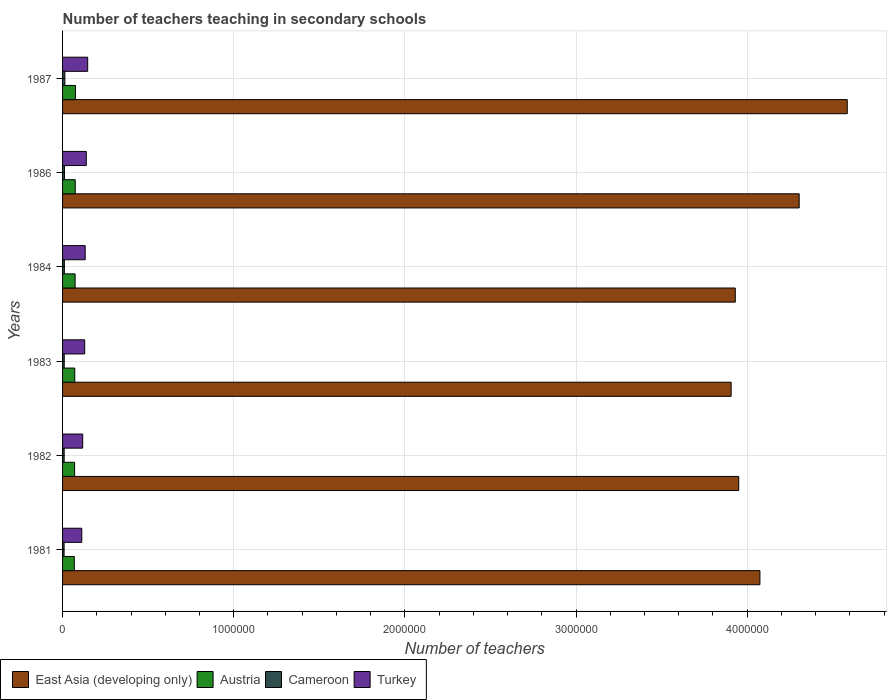How many groups of bars are there?
Your response must be concise. 6. How many bars are there on the 2nd tick from the bottom?
Keep it short and to the point. 4. What is the label of the 2nd group of bars from the top?
Your answer should be compact. 1986. In how many cases, is the number of bars for a given year not equal to the number of legend labels?
Your answer should be very brief. 0. What is the number of teachers teaching in secondary schools in Turkey in 1987?
Offer a terse response. 1.47e+05. Across all years, what is the maximum number of teachers teaching in secondary schools in Austria?
Provide a succinct answer. 7.53e+04. Across all years, what is the minimum number of teachers teaching in secondary schools in Austria?
Your response must be concise. 6.85e+04. In which year was the number of teachers teaching in secondary schools in Turkey maximum?
Offer a very short reply. 1987. What is the total number of teachers teaching in secondary schools in Turkey in the graph?
Your response must be concise. 7.77e+05. What is the difference between the number of teachers teaching in secondary schools in East Asia (developing only) in 1982 and that in 1986?
Ensure brevity in your answer.  -3.53e+05. What is the difference between the number of teachers teaching in secondary schools in Cameroon in 1987 and the number of teachers teaching in secondary schools in Turkey in 1983?
Your answer should be compact. -1.16e+05. What is the average number of teachers teaching in secondary schools in East Asia (developing only) per year?
Your answer should be very brief. 4.13e+06. In the year 1986, what is the difference between the number of teachers teaching in secondary schools in Austria and number of teachers teaching in secondary schools in Cameroon?
Your answer should be very brief. 6.29e+04. In how many years, is the number of teachers teaching in secondary schools in Turkey greater than 2200000 ?
Provide a short and direct response. 0. What is the ratio of the number of teachers teaching in secondary schools in Austria in 1981 to that in 1987?
Your response must be concise. 0.91. Is the number of teachers teaching in secondary schools in Austria in 1981 less than that in 1984?
Give a very brief answer. Yes. What is the difference between the highest and the second highest number of teachers teaching in secondary schools in Turkey?
Offer a terse response. 8159. What is the difference between the highest and the lowest number of teachers teaching in secondary schools in Turkey?
Provide a succinct answer. 3.46e+04. Is the sum of the number of teachers teaching in secondary schools in East Asia (developing only) in 1983 and 1987 greater than the maximum number of teachers teaching in secondary schools in Turkey across all years?
Offer a very short reply. Yes. What does the 4th bar from the top in 1983 represents?
Offer a very short reply. East Asia (developing only). What does the 1st bar from the bottom in 1981 represents?
Provide a succinct answer. East Asia (developing only). How many bars are there?
Offer a terse response. 24. Are the values on the major ticks of X-axis written in scientific E-notation?
Provide a succinct answer. No. Does the graph contain any zero values?
Offer a terse response. No. Where does the legend appear in the graph?
Your answer should be very brief. Bottom left. How are the legend labels stacked?
Offer a very short reply. Horizontal. What is the title of the graph?
Your answer should be compact. Number of teachers teaching in secondary schools. What is the label or title of the X-axis?
Offer a terse response. Number of teachers. What is the label or title of the Y-axis?
Offer a terse response. Years. What is the Number of teachers in East Asia (developing only) in 1981?
Your answer should be very brief. 4.07e+06. What is the Number of teachers in Austria in 1981?
Give a very brief answer. 6.85e+04. What is the Number of teachers in Cameroon in 1981?
Keep it short and to the point. 8926. What is the Number of teachers in Turkey in 1981?
Your response must be concise. 1.12e+05. What is the Number of teachers of East Asia (developing only) in 1982?
Your answer should be very brief. 3.95e+06. What is the Number of teachers in Austria in 1982?
Give a very brief answer. 7.04e+04. What is the Number of teachers of Cameroon in 1982?
Offer a very short reply. 9335. What is the Number of teachers of Turkey in 1982?
Ensure brevity in your answer.  1.18e+05. What is the Number of teachers of East Asia (developing only) in 1983?
Your answer should be compact. 3.91e+06. What is the Number of teachers of Austria in 1983?
Give a very brief answer. 7.13e+04. What is the Number of teachers of Cameroon in 1983?
Offer a terse response. 9680. What is the Number of teachers of Turkey in 1983?
Give a very brief answer. 1.29e+05. What is the Number of teachers in East Asia (developing only) in 1984?
Make the answer very short. 3.93e+06. What is the Number of teachers in Austria in 1984?
Provide a short and direct response. 7.33e+04. What is the Number of teachers of Cameroon in 1984?
Offer a terse response. 1.04e+04. What is the Number of teachers in Turkey in 1984?
Ensure brevity in your answer.  1.32e+05. What is the Number of teachers in East Asia (developing only) in 1986?
Provide a succinct answer. 4.30e+06. What is the Number of teachers in Austria in 1986?
Offer a very short reply. 7.40e+04. What is the Number of teachers in Cameroon in 1986?
Provide a succinct answer. 1.11e+04. What is the Number of teachers of Turkey in 1986?
Give a very brief answer. 1.39e+05. What is the Number of teachers in East Asia (developing only) in 1987?
Make the answer very short. 4.58e+06. What is the Number of teachers of Austria in 1987?
Give a very brief answer. 7.53e+04. What is the Number of teachers in Cameroon in 1987?
Your response must be concise. 1.34e+04. What is the Number of teachers in Turkey in 1987?
Keep it short and to the point. 1.47e+05. Across all years, what is the maximum Number of teachers in East Asia (developing only)?
Your answer should be very brief. 4.58e+06. Across all years, what is the maximum Number of teachers in Austria?
Keep it short and to the point. 7.53e+04. Across all years, what is the maximum Number of teachers of Cameroon?
Ensure brevity in your answer.  1.34e+04. Across all years, what is the maximum Number of teachers of Turkey?
Provide a succinct answer. 1.47e+05. Across all years, what is the minimum Number of teachers in East Asia (developing only)?
Your answer should be very brief. 3.91e+06. Across all years, what is the minimum Number of teachers in Austria?
Your answer should be compact. 6.85e+04. Across all years, what is the minimum Number of teachers of Cameroon?
Your answer should be compact. 8926. Across all years, what is the minimum Number of teachers in Turkey?
Make the answer very short. 1.12e+05. What is the total Number of teachers of East Asia (developing only) in the graph?
Give a very brief answer. 2.48e+07. What is the total Number of teachers in Austria in the graph?
Keep it short and to the point. 4.33e+05. What is the total Number of teachers of Cameroon in the graph?
Your answer should be compact. 6.28e+04. What is the total Number of teachers of Turkey in the graph?
Make the answer very short. 7.77e+05. What is the difference between the Number of teachers in East Asia (developing only) in 1981 and that in 1982?
Make the answer very short. 1.24e+05. What is the difference between the Number of teachers of Austria in 1981 and that in 1982?
Your answer should be very brief. -1866. What is the difference between the Number of teachers in Cameroon in 1981 and that in 1982?
Provide a short and direct response. -409. What is the difference between the Number of teachers in Turkey in 1981 and that in 1982?
Offer a very short reply. -5466. What is the difference between the Number of teachers of East Asia (developing only) in 1981 and that in 1983?
Your response must be concise. 1.68e+05. What is the difference between the Number of teachers in Austria in 1981 and that in 1983?
Keep it short and to the point. -2820. What is the difference between the Number of teachers in Cameroon in 1981 and that in 1983?
Offer a very short reply. -754. What is the difference between the Number of teachers of Turkey in 1981 and that in 1983?
Offer a terse response. -1.71e+04. What is the difference between the Number of teachers of East Asia (developing only) in 1981 and that in 1984?
Make the answer very short. 1.44e+05. What is the difference between the Number of teachers of Austria in 1981 and that in 1984?
Your response must be concise. -4759. What is the difference between the Number of teachers of Cameroon in 1981 and that in 1984?
Make the answer very short. -1513. What is the difference between the Number of teachers in Turkey in 1981 and that in 1984?
Provide a short and direct response. -2.00e+04. What is the difference between the Number of teachers of East Asia (developing only) in 1981 and that in 1986?
Ensure brevity in your answer.  -2.29e+05. What is the difference between the Number of teachers of Austria in 1981 and that in 1986?
Keep it short and to the point. -5522. What is the difference between the Number of teachers of Cameroon in 1981 and that in 1986?
Offer a terse response. -2170. What is the difference between the Number of teachers in Turkey in 1981 and that in 1986?
Provide a short and direct response. -2.65e+04. What is the difference between the Number of teachers in East Asia (developing only) in 1981 and that in 1987?
Ensure brevity in your answer.  -5.10e+05. What is the difference between the Number of teachers in Austria in 1981 and that in 1987?
Give a very brief answer. -6764. What is the difference between the Number of teachers of Cameroon in 1981 and that in 1987?
Your answer should be very brief. -4444. What is the difference between the Number of teachers of Turkey in 1981 and that in 1987?
Offer a very short reply. -3.46e+04. What is the difference between the Number of teachers in East Asia (developing only) in 1982 and that in 1983?
Provide a short and direct response. 4.44e+04. What is the difference between the Number of teachers of Austria in 1982 and that in 1983?
Offer a terse response. -954. What is the difference between the Number of teachers of Cameroon in 1982 and that in 1983?
Ensure brevity in your answer.  -345. What is the difference between the Number of teachers in Turkey in 1982 and that in 1983?
Offer a very short reply. -1.16e+04. What is the difference between the Number of teachers of East Asia (developing only) in 1982 and that in 1984?
Make the answer very short. 2.02e+04. What is the difference between the Number of teachers of Austria in 1982 and that in 1984?
Your answer should be very brief. -2893. What is the difference between the Number of teachers in Cameroon in 1982 and that in 1984?
Your response must be concise. -1104. What is the difference between the Number of teachers of Turkey in 1982 and that in 1984?
Your answer should be very brief. -1.46e+04. What is the difference between the Number of teachers in East Asia (developing only) in 1982 and that in 1986?
Ensure brevity in your answer.  -3.53e+05. What is the difference between the Number of teachers in Austria in 1982 and that in 1986?
Give a very brief answer. -3656. What is the difference between the Number of teachers of Cameroon in 1982 and that in 1986?
Keep it short and to the point. -1761. What is the difference between the Number of teachers in Turkey in 1982 and that in 1986?
Provide a short and direct response. -2.10e+04. What is the difference between the Number of teachers of East Asia (developing only) in 1982 and that in 1987?
Your answer should be compact. -6.34e+05. What is the difference between the Number of teachers in Austria in 1982 and that in 1987?
Offer a very short reply. -4898. What is the difference between the Number of teachers of Cameroon in 1982 and that in 1987?
Keep it short and to the point. -4035. What is the difference between the Number of teachers in Turkey in 1982 and that in 1987?
Offer a terse response. -2.92e+04. What is the difference between the Number of teachers in East Asia (developing only) in 1983 and that in 1984?
Make the answer very short. -2.42e+04. What is the difference between the Number of teachers of Austria in 1983 and that in 1984?
Offer a very short reply. -1939. What is the difference between the Number of teachers in Cameroon in 1983 and that in 1984?
Offer a terse response. -759. What is the difference between the Number of teachers of Turkey in 1983 and that in 1984?
Provide a succinct answer. -2949. What is the difference between the Number of teachers of East Asia (developing only) in 1983 and that in 1986?
Offer a terse response. -3.98e+05. What is the difference between the Number of teachers of Austria in 1983 and that in 1986?
Make the answer very short. -2702. What is the difference between the Number of teachers in Cameroon in 1983 and that in 1986?
Keep it short and to the point. -1416. What is the difference between the Number of teachers of Turkey in 1983 and that in 1986?
Provide a short and direct response. -9372. What is the difference between the Number of teachers of East Asia (developing only) in 1983 and that in 1987?
Give a very brief answer. -6.79e+05. What is the difference between the Number of teachers in Austria in 1983 and that in 1987?
Keep it short and to the point. -3944. What is the difference between the Number of teachers in Cameroon in 1983 and that in 1987?
Provide a short and direct response. -3690. What is the difference between the Number of teachers in Turkey in 1983 and that in 1987?
Offer a terse response. -1.75e+04. What is the difference between the Number of teachers in East Asia (developing only) in 1984 and that in 1986?
Make the answer very short. -3.73e+05. What is the difference between the Number of teachers of Austria in 1984 and that in 1986?
Give a very brief answer. -763. What is the difference between the Number of teachers of Cameroon in 1984 and that in 1986?
Your answer should be very brief. -657. What is the difference between the Number of teachers in Turkey in 1984 and that in 1986?
Offer a terse response. -6423. What is the difference between the Number of teachers of East Asia (developing only) in 1984 and that in 1987?
Offer a very short reply. -6.54e+05. What is the difference between the Number of teachers in Austria in 1984 and that in 1987?
Provide a short and direct response. -2005. What is the difference between the Number of teachers of Cameroon in 1984 and that in 1987?
Your answer should be very brief. -2931. What is the difference between the Number of teachers in Turkey in 1984 and that in 1987?
Keep it short and to the point. -1.46e+04. What is the difference between the Number of teachers in East Asia (developing only) in 1986 and that in 1987?
Offer a terse response. -2.81e+05. What is the difference between the Number of teachers in Austria in 1986 and that in 1987?
Your response must be concise. -1242. What is the difference between the Number of teachers in Cameroon in 1986 and that in 1987?
Provide a short and direct response. -2274. What is the difference between the Number of teachers of Turkey in 1986 and that in 1987?
Offer a very short reply. -8159. What is the difference between the Number of teachers of East Asia (developing only) in 1981 and the Number of teachers of Austria in 1982?
Your answer should be very brief. 4.00e+06. What is the difference between the Number of teachers of East Asia (developing only) in 1981 and the Number of teachers of Cameroon in 1982?
Give a very brief answer. 4.07e+06. What is the difference between the Number of teachers of East Asia (developing only) in 1981 and the Number of teachers of Turkey in 1982?
Your response must be concise. 3.96e+06. What is the difference between the Number of teachers in Austria in 1981 and the Number of teachers in Cameroon in 1982?
Offer a very short reply. 5.92e+04. What is the difference between the Number of teachers in Austria in 1981 and the Number of teachers in Turkey in 1982?
Your response must be concise. -4.92e+04. What is the difference between the Number of teachers in Cameroon in 1981 and the Number of teachers in Turkey in 1982?
Your answer should be very brief. -1.09e+05. What is the difference between the Number of teachers of East Asia (developing only) in 1981 and the Number of teachers of Austria in 1983?
Provide a succinct answer. 4.00e+06. What is the difference between the Number of teachers of East Asia (developing only) in 1981 and the Number of teachers of Cameroon in 1983?
Make the answer very short. 4.06e+06. What is the difference between the Number of teachers of East Asia (developing only) in 1981 and the Number of teachers of Turkey in 1983?
Offer a terse response. 3.95e+06. What is the difference between the Number of teachers in Austria in 1981 and the Number of teachers in Cameroon in 1983?
Provide a succinct answer. 5.88e+04. What is the difference between the Number of teachers in Austria in 1981 and the Number of teachers in Turkey in 1983?
Your response must be concise. -6.08e+04. What is the difference between the Number of teachers of Cameroon in 1981 and the Number of teachers of Turkey in 1983?
Offer a terse response. -1.20e+05. What is the difference between the Number of teachers in East Asia (developing only) in 1981 and the Number of teachers in Austria in 1984?
Provide a succinct answer. 4.00e+06. What is the difference between the Number of teachers of East Asia (developing only) in 1981 and the Number of teachers of Cameroon in 1984?
Your answer should be compact. 4.06e+06. What is the difference between the Number of teachers in East Asia (developing only) in 1981 and the Number of teachers in Turkey in 1984?
Your answer should be very brief. 3.94e+06. What is the difference between the Number of teachers in Austria in 1981 and the Number of teachers in Cameroon in 1984?
Your answer should be compact. 5.81e+04. What is the difference between the Number of teachers in Austria in 1981 and the Number of teachers in Turkey in 1984?
Make the answer very short. -6.37e+04. What is the difference between the Number of teachers in Cameroon in 1981 and the Number of teachers in Turkey in 1984?
Keep it short and to the point. -1.23e+05. What is the difference between the Number of teachers in East Asia (developing only) in 1981 and the Number of teachers in Austria in 1986?
Provide a succinct answer. 4.00e+06. What is the difference between the Number of teachers of East Asia (developing only) in 1981 and the Number of teachers of Cameroon in 1986?
Offer a very short reply. 4.06e+06. What is the difference between the Number of teachers in East Asia (developing only) in 1981 and the Number of teachers in Turkey in 1986?
Make the answer very short. 3.94e+06. What is the difference between the Number of teachers of Austria in 1981 and the Number of teachers of Cameroon in 1986?
Your answer should be compact. 5.74e+04. What is the difference between the Number of teachers in Austria in 1981 and the Number of teachers in Turkey in 1986?
Provide a short and direct response. -7.01e+04. What is the difference between the Number of teachers of Cameroon in 1981 and the Number of teachers of Turkey in 1986?
Your answer should be compact. -1.30e+05. What is the difference between the Number of teachers of East Asia (developing only) in 1981 and the Number of teachers of Austria in 1987?
Offer a very short reply. 4.00e+06. What is the difference between the Number of teachers of East Asia (developing only) in 1981 and the Number of teachers of Cameroon in 1987?
Your response must be concise. 4.06e+06. What is the difference between the Number of teachers in East Asia (developing only) in 1981 and the Number of teachers in Turkey in 1987?
Provide a succinct answer. 3.93e+06. What is the difference between the Number of teachers of Austria in 1981 and the Number of teachers of Cameroon in 1987?
Ensure brevity in your answer.  5.51e+04. What is the difference between the Number of teachers in Austria in 1981 and the Number of teachers in Turkey in 1987?
Keep it short and to the point. -7.83e+04. What is the difference between the Number of teachers in Cameroon in 1981 and the Number of teachers in Turkey in 1987?
Provide a short and direct response. -1.38e+05. What is the difference between the Number of teachers in East Asia (developing only) in 1982 and the Number of teachers in Austria in 1983?
Keep it short and to the point. 3.88e+06. What is the difference between the Number of teachers in East Asia (developing only) in 1982 and the Number of teachers in Cameroon in 1983?
Your answer should be very brief. 3.94e+06. What is the difference between the Number of teachers of East Asia (developing only) in 1982 and the Number of teachers of Turkey in 1983?
Provide a succinct answer. 3.82e+06. What is the difference between the Number of teachers in Austria in 1982 and the Number of teachers in Cameroon in 1983?
Keep it short and to the point. 6.07e+04. What is the difference between the Number of teachers in Austria in 1982 and the Number of teachers in Turkey in 1983?
Offer a very short reply. -5.89e+04. What is the difference between the Number of teachers in Cameroon in 1982 and the Number of teachers in Turkey in 1983?
Your answer should be compact. -1.20e+05. What is the difference between the Number of teachers in East Asia (developing only) in 1982 and the Number of teachers in Austria in 1984?
Make the answer very short. 3.88e+06. What is the difference between the Number of teachers of East Asia (developing only) in 1982 and the Number of teachers of Cameroon in 1984?
Offer a terse response. 3.94e+06. What is the difference between the Number of teachers in East Asia (developing only) in 1982 and the Number of teachers in Turkey in 1984?
Offer a very short reply. 3.82e+06. What is the difference between the Number of teachers of Austria in 1982 and the Number of teachers of Cameroon in 1984?
Ensure brevity in your answer.  5.99e+04. What is the difference between the Number of teachers in Austria in 1982 and the Number of teachers in Turkey in 1984?
Ensure brevity in your answer.  -6.19e+04. What is the difference between the Number of teachers of Cameroon in 1982 and the Number of teachers of Turkey in 1984?
Make the answer very short. -1.23e+05. What is the difference between the Number of teachers of East Asia (developing only) in 1982 and the Number of teachers of Austria in 1986?
Keep it short and to the point. 3.88e+06. What is the difference between the Number of teachers in East Asia (developing only) in 1982 and the Number of teachers in Cameroon in 1986?
Your answer should be compact. 3.94e+06. What is the difference between the Number of teachers in East Asia (developing only) in 1982 and the Number of teachers in Turkey in 1986?
Provide a succinct answer. 3.81e+06. What is the difference between the Number of teachers in Austria in 1982 and the Number of teachers in Cameroon in 1986?
Give a very brief answer. 5.93e+04. What is the difference between the Number of teachers of Austria in 1982 and the Number of teachers of Turkey in 1986?
Provide a short and direct response. -6.83e+04. What is the difference between the Number of teachers in Cameroon in 1982 and the Number of teachers in Turkey in 1986?
Your response must be concise. -1.29e+05. What is the difference between the Number of teachers in East Asia (developing only) in 1982 and the Number of teachers in Austria in 1987?
Ensure brevity in your answer.  3.88e+06. What is the difference between the Number of teachers of East Asia (developing only) in 1982 and the Number of teachers of Cameroon in 1987?
Provide a succinct answer. 3.94e+06. What is the difference between the Number of teachers of East Asia (developing only) in 1982 and the Number of teachers of Turkey in 1987?
Give a very brief answer. 3.80e+06. What is the difference between the Number of teachers in Austria in 1982 and the Number of teachers in Cameroon in 1987?
Offer a terse response. 5.70e+04. What is the difference between the Number of teachers of Austria in 1982 and the Number of teachers of Turkey in 1987?
Provide a succinct answer. -7.64e+04. What is the difference between the Number of teachers of Cameroon in 1982 and the Number of teachers of Turkey in 1987?
Offer a terse response. -1.37e+05. What is the difference between the Number of teachers of East Asia (developing only) in 1983 and the Number of teachers of Austria in 1984?
Your response must be concise. 3.83e+06. What is the difference between the Number of teachers in East Asia (developing only) in 1983 and the Number of teachers in Cameroon in 1984?
Offer a very short reply. 3.90e+06. What is the difference between the Number of teachers in East Asia (developing only) in 1983 and the Number of teachers in Turkey in 1984?
Offer a very short reply. 3.77e+06. What is the difference between the Number of teachers in Austria in 1983 and the Number of teachers in Cameroon in 1984?
Your answer should be compact. 6.09e+04. What is the difference between the Number of teachers of Austria in 1983 and the Number of teachers of Turkey in 1984?
Your response must be concise. -6.09e+04. What is the difference between the Number of teachers of Cameroon in 1983 and the Number of teachers of Turkey in 1984?
Your response must be concise. -1.23e+05. What is the difference between the Number of teachers of East Asia (developing only) in 1983 and the Number of teachers of Austria in 1986?
Offer a very short reply. 3.83e+06. What is the difference between the Number of teachers in East Asia (developing only) in 1983 and the Number of teachers in Cameroon in 1986?
Ensure brevity in your answer.  3.90e+06. What is the difference between the Number of teachers of East Asia (developing only) in 1983 and the Number of teachers of Turkey in 1986?
Make the answer very short. 3.77e+06. What is the difference between the Number of teachers of Austria in 1983 and the Number of teachers of Cameroon in 1986?
Your answer should be compact. 6.02e+04. What is the difference between the Number of teachers in Austria in 1983 and the Number of teachers in Turkey in 1986?
Give a very brief answer. -6.73e+04. What is the difference between the Number of teachers of Cameroon in 1983 and the Number of teachers of Turkey in 1986?
Offer a terse response. -1.29e+05. What is the difference between the Number of teachers in East Asia (developing only) in 1983 and the Number of teachers in Austria in 1987?
Offer a very short reply. 3.83e+06. What is the difference between the Number of teachers of East Asia (developing only) in 1983 and the Number of teachers of Cameroon in 1987?
Ensure brevity in your answer.  3.89e+06. What is the difference between the Number of teachers of East Asia (developing only) in 1983 and the Number of teachers of Turkey in 1987?
Provide a short and direct response. 3.76e+06. What is the difference between the Number of teachers of Austria in 1983 and the Number of teachers of Cameroon in 1987?
Keep it short and to the point. 5.79e+04. What is the difference between the Number of teachers in Austria in 1983 and the Number of teachers in Turkey in 1987?
Your response must be concise. -7.55e+04. What is the difference between the Number of teachers in Cameroon in 1983 and the Number of teachers in Turkey in 1987?
Make the answer very short. -1.37e+05. What is the difference between the Number of teachers of East Asia (developing only) in 1984 and the Number of teachers of Austria in 1986?
Offer a terse response. 3.86e+06. What is the difference between the Number of teachers of East Asia (developing only) in 1984 and the Number of teachers of Cameroon in 1986?
Offer a very short reply. 3.92e+06. What is the difference between the Number of teachers of East Asia (developing only) in 1984 and the Number of teachers of Turkey in 1986?
Your response must be concise. 3.79e+06. What is the difference between the Number of teachers in Austria in 1984 and the Number of teachers in Cameroon in 1986?
Make the answer very short. 6.22e+04. What is the difference between the Number of teachers in Austria in 1984 and the Number of teachers in Turkey in 1986?
Offer a very short reply. -6.54e+04. What is the difference between the Number of teachers of Cameroon in 1984 and the Number of teachers of Turkey in 1986?
Make the answer very short. -1.28e+05. What is the difference between the Number of teachers of East Asia (developing only) in 1984 and the Number of teachers of Austria in 1987?
Make the answer very short. 3.86e+06. What is the difference between the Number of teachers in East Asia (developing only) in 1984 and the Number of teachers in Cameroon in 1987?
Your response must be concise. 3.92e+06. What is the difference between the Number of teachers in East Asia (developing only) in 1984 and the Number of teachers in Turkey in 1987?
Offer a very short reply. 3.78e+06. What is the difference between the Number of teachers in Austria in 1984 and the Number of teachers in Cameroon in 1987?
Your answer should be compact. 5.99e+04. What is the difference between the Number of teachers in Austria in 1984 and the Number of teachers in Turkey in 1987?
Offer a very short reply. -7.35e+04. What is the difference between the Number of teachers in Cameroon in 1984 and the Number of teachers in Turkey in 1987?
Provide a short and direct response. -1.36e+05. What is the difference between the Number of teachers of East Asia (developing only) in 1986 and the Number of teachers of Austria in 1987?
Make the answer very short. 4.23e+06. What is the difference between the Number of teachers of East Asia (developing only) in 1986 and the Number of teachers of Cameroon in 1987?
Your answer should be very brief. 4.29e+06. What is the difference between the Number of teachers of East Asia (developing only) in 1986 and the Number of teachers of Turkey in 1987?
Provide a short and direct response. 4.16e+06. What is the difference between the Number of teachers of Austria in 1986 and the Number of teachers of Cameroon in 1987?
Ensure brevity in your answer.  6.06e+04. What is the difference between the Number of teachers in Austria in 1986 and the Number of teachers in Turkey in 1987?
Provide a short and direct response. -7.28e+04. What is the difference between the Number of teachers of Cameroon in 1986 and the Number of teachers of Turkey in 1987?
Give a very brief answer. -1.36e+05. What is the average Number of teachers in East Asia (developing only) per year?
Your answer should be compact. 4.13e+06. What is the average Number of teachers of Austria per year?
Offer a very short reply. 7.21e+04. What is the average Number of teachers of Cameroon per year?
Your answer should be very brief. 1.05e+04. What is the average Number of teachers in Turkey per year?
Your response must be concise. 1.29e+05. In the year 1981, what is the difference between the Number of teachers in East Asia (developing only) and Number of teachers in Austria?
Your answer should be very brief. 4.01e+06. In the year 1981, what is the difference between the Number of teachers of East Asia (developing only) and Number of teachers of Cameroon?
Your answer should be compact. 4.07e+06. In the year 1981, what is the difference between the Number of teachers of East Asia (developing only) and Number of teachers of Turkey?
Make the answer very short. 3.96e+06. In the year 1981, what is the difference between the Number of teachers in Austria and Number of teachers in Cameroon?
Offer a very short reply. 5.96e+04. In the year 1981, what is the difference between the Number of teachers of Austria and Number of teachers of Turkey?
Provide a succinct answer. -4.37e+04. In the year 1981, what is the difference between the Number of teachers in Cameroon and Number of teachers in Turkey?
Give a very brief answer. -1.03e+05. In the year 1982, what is the difference between the Number of teachers in East Asia (developing only) and Number of teachers in Austria?
Offer a very short reply. 3.88e+06. In the year 1982, what is the difference between the Number of teachers in East Asia (developing only) and Number of teachers in Cameroon?
Make the answer very short. 3.94e+06. In the year 1982, what is the difference between the Number of teachers in East Asia (developing only) and Number of teachers in Turkey?
Your response must be concise. 3.83e+06. In the year 1982, what is the difference between the Number of teachers of Austria and Number of teachers of Cameroon?
Give a very brief answer. 6.10e+04. In the year 1982, what is the difference between the Number of teachers in Austria and Number of teachers in Turkey?
Your response must be concise. -4.73e+04. In the year 1982, what is the difference between the Number of teachers of Cameroon and Number of teachers of Turkey?
Give a very brief answer. -1.08e+05. In the year 1983, what is the difference between the Number of teachers of East Asia (developing only) and Number of teachers of Austria?
Keep it short and to the point. 3.84e+06. In the year 1983, what is the difference between the Number of teachers of East Asia (developing only) and Number of teachers of Cameroon?
Provide a short and direct response. 3.90e+06. In the year 1983, what is the difference between the Number of teachers in East Asia (developing only) and Number of teachers in Turkey?
Ensure brevity in your answer.  3.78e+06. In the year 1983, what is the difference between the Number of teachers of Austria and Number of teachers of Cameroon?
Give a very brief answer. 6.16e+04. In the year 1983, what is the difference between the Number of teachers in Austria and Number of teachers in Turkey?
Your answer should be compact. -5.80e+04. In the year 1983, what is the difference between the Number of teachers of Cameroon and Number of teachers of Turkey?
Provide a succinct answer. -1.20e+05. In the year 1984, what is the difference between the Number of teachers of East Asia (developing only) and Number of teachers of Austria?
Provide a short and direct response. 3.86e+06. In the year 1984, what is the difference between the Number of teachers in East Asia (developing only) and Number of teachers in Cameroon?
Offer a terse response. 3.92e+06. In the year 1984, what is the difference between the Number of teachers of East Asia (developing only) and Number of teachers of Turkey?
Your answer should be compact. 3.80e+06. In the year 1984, what is the difference between the Number of teachers in Austria and Number of teachers in Cameroon?
Offer a terse response. 6.28e+04. In the year 1984, what is the difference between the Number of teachers in Austria and Number of teachers in Turkey?
Offer a very short reply. -5.90e+04. In the year 1984, what is the difference between the Number of teachers in Cameroon and Number of teachers in Turkey?
Your answer should be compact. -1.22e+05. In the year 1986, what is the difference between the Number of teachers in East Asia (developing only) and Number of teachers in Austria?
Offer a terse response. 4.23e+06. In the year 1986, what is the difference between the Number of teachers of East Asia (developing only) and Number of teachers of Cameroon?
Your response must be concise. 4.29e+06. In the year 1986, what is the difference between the Number of teachers in East Asia (developing only) and Number of teachers in Turkey?
Your answer should be compact. 4.17e+06. In the year 1986, what is the difference between the Number of teachers of Austria and Number of teachers of Cameroon?
Provide a short and direct response. 6.29e+04. In the year 1986, what is the difference between the Number of teachers of Austria and Number of teachers of Turkey?
Ensure brevity in your answer.  -6.46e+04. In the year 1986, what is the difference between the Number of teachers in Cameroon and Number of teachers in Turkey?
Offer a very short reply. -1.28e+05. In the year 1987, what is the difference between the Number of teachers in East Asia (developing only) and Number of teachers in Austria?
Your answer should be compact. 4.51e+06. In the year 1987, what is the difference between the Number of teachers of East Asia (developing only) and Number of teachers of Cameroon?
Your answer should be compact. 4.57e+06. In the year 1987, what is the difference between the Number of teachers in East Asia (developing only) and Number of teachers in Turkey?
Ensure brevity in your answer.  4.44e+06. In the year 1987, what is the difference between the Number of teachers in Austria and Number of teachers in Cameroon?
Offer a very short reply. 6.19e+04. In the year 1987, what is the difference between the Number of teachers in Austria and Number of teachers in Turkey?
Ensure brevity in your answer.  -7.15e+04. In the year 1987, what is the difference between the Number of teachers in Cameroon and Number of teachers in Turkey?
Offer a terse response. -1.33e+05. What is the ratio of the Number of teachers in East Asia (developing only) in 1981 to that in 1982?
Keep it short and to the point. 1.03. What is the ratio of the Number of teachers in Austria in 1981 to that in 1982?
Provide a succinct answer. 0.97. What is the ratio of the Number of teachers in Cameroon in 1981 to that in 1982?
Make the answer very short. 0.96. What is the ratio of the Number of teachers of Turkey in 1981 to that in 1982?
Offer a terse response. 0.95. What is the ratio of the Number of teachers in East Asia (developing only) in 1981 to that in 1983?
Your answer should be very brief. 1.04. What is the ratio of the Number of teachers in Austria in 1981 to that in 1983?
Make the answer very short. 0.96. What is the ratio of the Number of teachers in Cameroon in 1981 to that in 1983?
Your answer should be compact. 0.92. What is the ratio of the Number of teachers of Turkey in 1981 to that in 1983?
Your answer should be compact. 0.87. What is the ratio of the Number of teachers in East Asia (developing only) in 1981 to that in 1984?
Keep it short and to the point. 1.04. What is the ratio of the Number of teachers in Austria in 1981 to that in 1984?
Provide a succinct answer. 0.94. What is the ratio of the Number of teachers in Cameroon in 1981 to that in 1984?
Your answer should be very brief. 0.86. What is the ratio of the Number of teachers of Turkey in 1981 to that in 1984?
Provide a succinct answer. 0.85. What is the ratio of the Number of teachers in East Asia (developing only) in 1981 to that in 1986?
Offer a terse response. 0.95. What is the ratio of the Number of teachers of Austria in 1981 to that in 1986?
Ensure brevity in your answer.  0.93. What is the ratio of the Number of teachers in Cameroon in 1981 to that in 1986?
Offer a very short reply. 0.8. What is the ratio of the Number of teachers of Turkey in 1981 to that in 1986?
Keep it short and to the point. 0.81. What is the ratio of the Number of teachers of East Asia (developing only) in 1981 to that in 1987?
Ensure brevity in your answer.  0.89. What is the ratio of the Number of teachers of Austria in 1981 to that in 1987?
Offer a very short reply. 0.91. What is the ratio of the Number of teachers in Cameroon in 1981 to that in 1987?
Provide a short and direct response. 0.67. What is the ratio of the Number of teachers of Turkey in 1981 to that in 1987?
Offer a very short reply. 0.76. What is the ratio of the Number of teachers in East Asia (developing only) in 1982 to that in 1983?
Ensure brevity in your answer.  1.01. What is the ratio of the Number of teachers in Austria in 1982 to that in 1983?
Your response must be concise. 0.99. What is the ratio of the Number of teachers of Cameroon in 1982 to that in 1983?
Your response must be concise. 0.96. What is the ratio of the Number of teachers of Turkey in 1982 to that in 1983?
Your answer should be compact. 0.91. What is the ratio of the Number of teachers in East Asia (developing only) in 1982 to that in 1984?
Ensure brevity in your answer.  1.01. What is the ratio of the Number of teachers in Austria in 1982 to that in 1984?
Make the answer very short. 0.96. What is the ratio of the Number of teachers of Cameroon in 1982 to that in 1984?
Give a very brief answer. 0.89. What is the ratio of the Number of teachers of Turkey in 1982 to that in 1984?
Your answer should be compact. 0.89. What is the ratio of the Number of teachers of East Asia (developing only) in 1982 to that in 1986?
Provide a short and direct response. 0.92. What is the ratio of the Number of teachers of Austria in 1982 to that in 1986?
Offer a terse response. 0.95. What is the ratio of the Number of teachers in Cameroon in 1982 to that in 1986?
Provide a short and direct response. 0.84. What is the ratio of the Number of teachers in Turkey in 1982 to that in 1986?
Provide a succinct answer. 0.85. What is the ratio of the Number of teachers of East Asia (developing only) in 1982 to that in 1987?
Provide a succinct answer. 0.86. What is the ratio of the Number of teachers of Austria in 1982 to that in 1987?
Give a very brief answer. 0.93. What is the ratio of the Number of teachers in Cameroon in 1982 to that in 1987?
Provide a succinct answer. 0.7. What is the ratio of the Number of teachers of Turkey in 1982 to that in 1987?
Provide a short and direct response. 0.8. What is the ratio of the Number of teachers in Austria in 1983 to that in 1984?
Ensure brevity in your answer.  0.97. What is the ratio of the Number of teachers of Cameroon in 1983 to that in 1984?
Your answer should be very brief. 0.93. What is the ratio of the Number of teachers in Turkey in 1983 to that in 1984?
Give a very brief answer. 0.98. What is the ratio of the Number of teachers of East Asia (developing only) in 1983 to that in 1986?
Ensure brevity in your answer.  0.91. What is the ratio of the Number of teachers of Austria in 1983 to that in 1986?
Offer a terse response. 0.96. What is the ratio of the Number of teachers of Cameroon in 1983 to that in 1986?
Make the answer very short. 0.87. What is the ratio of the Number of teachers of Turkey in 1983 to that in 1986?
Offer a terse response. 0.93. What is the ratio of the Number of teachers of East Asia (developing only) in 1983 to that in 1987?
Offer a very short reply. 0.85. What is the ratio of the Number of teachers in Austria in 1983 to that in 1987?
Offer a terse response. 0.95. What is the ratio of the Number of teachers of Cameroon in 1983 to that in 1987?
Your response must be concise. 0.72. What is the ratio of the Number of teachers in Turkey in 1983 to that in 1987?
Make the answer very short. 0.88. What is the ratio of the Number of teachers of East Asia (developing only) in 1984 to that in 1986?
Ensure brevity in your answer.  0.91. What is the ratio of the Number of teachers in Austria in 1984 to that in 1986?
Offer a very short reply. 0.99. What is the ratio of the Number of teachers in Cameroon in 1984 to that in 1986?
Offer a very short reply. 0.94. What is the ratio of the Number of teachers in Turkey in 1984 to that in 1986?
Your answer should be very brief. 0.95. What is the ratio of the Number of teachers of East Asia (developing only) in 1984 to that in 1987?
Your answer should be very brief. 0.86. What is the ratio of the Number of teachers in Austria in 1984 to that in 1987?
Your answer should be very brief. 0.97. What is the ratio of the Number of teachers in Cameroon in 1984 to that in 1987?
Your answer should be compact. 0.78. What is the ratio of the Number of teachers of Turkey in 1984 to that in 1987?
Provide a succinct answer. 0.9. What is the ratio of the Number of teachers of East Asia (developing only) in 1986 to that in 1987?
Provide a short and direct response. 0.94. What is the ratio of the Number of teachers of Austria in 1986 to that in 1987?
Offer a terse response. 0.98. What is the ratio of the Number of teachers of Cameroon in 1986 to that in 1987?
Your answer should be very brief. 0.83. What is the difference between the highest and the second highest Number of teachers in East Asia (developing only)?
Provide a succinct answer. 2.81e+05. What is the difference between the highest and the second highest Number of teachers in Austria?
Ensure brevity in your answer.  1242. What is the difference between the highest and the second highest Number of teachers in Cameroon?
Your answer should be compact. 2274. What is the difference between the highest and the second highest Number of teachers in Turkey?
Your answer should be very brief. 8159. What is the difference between the highest and the lowest Number of teachers in East Asia (developing only)?
Provide a short and direct response. 6.79e+05. What is the difference between the highest and the lowest Number of teachers in Austria?
Ensure brevity in your answer.  6764. What is the difference between the highest and the lowest Number of teachers of Cameroon?
Keep it short and to the point. 4444. What is the difference between the highest and the lowest Number of teachers in Turkey?
Keep it short and to the point. 3.46e+04. 